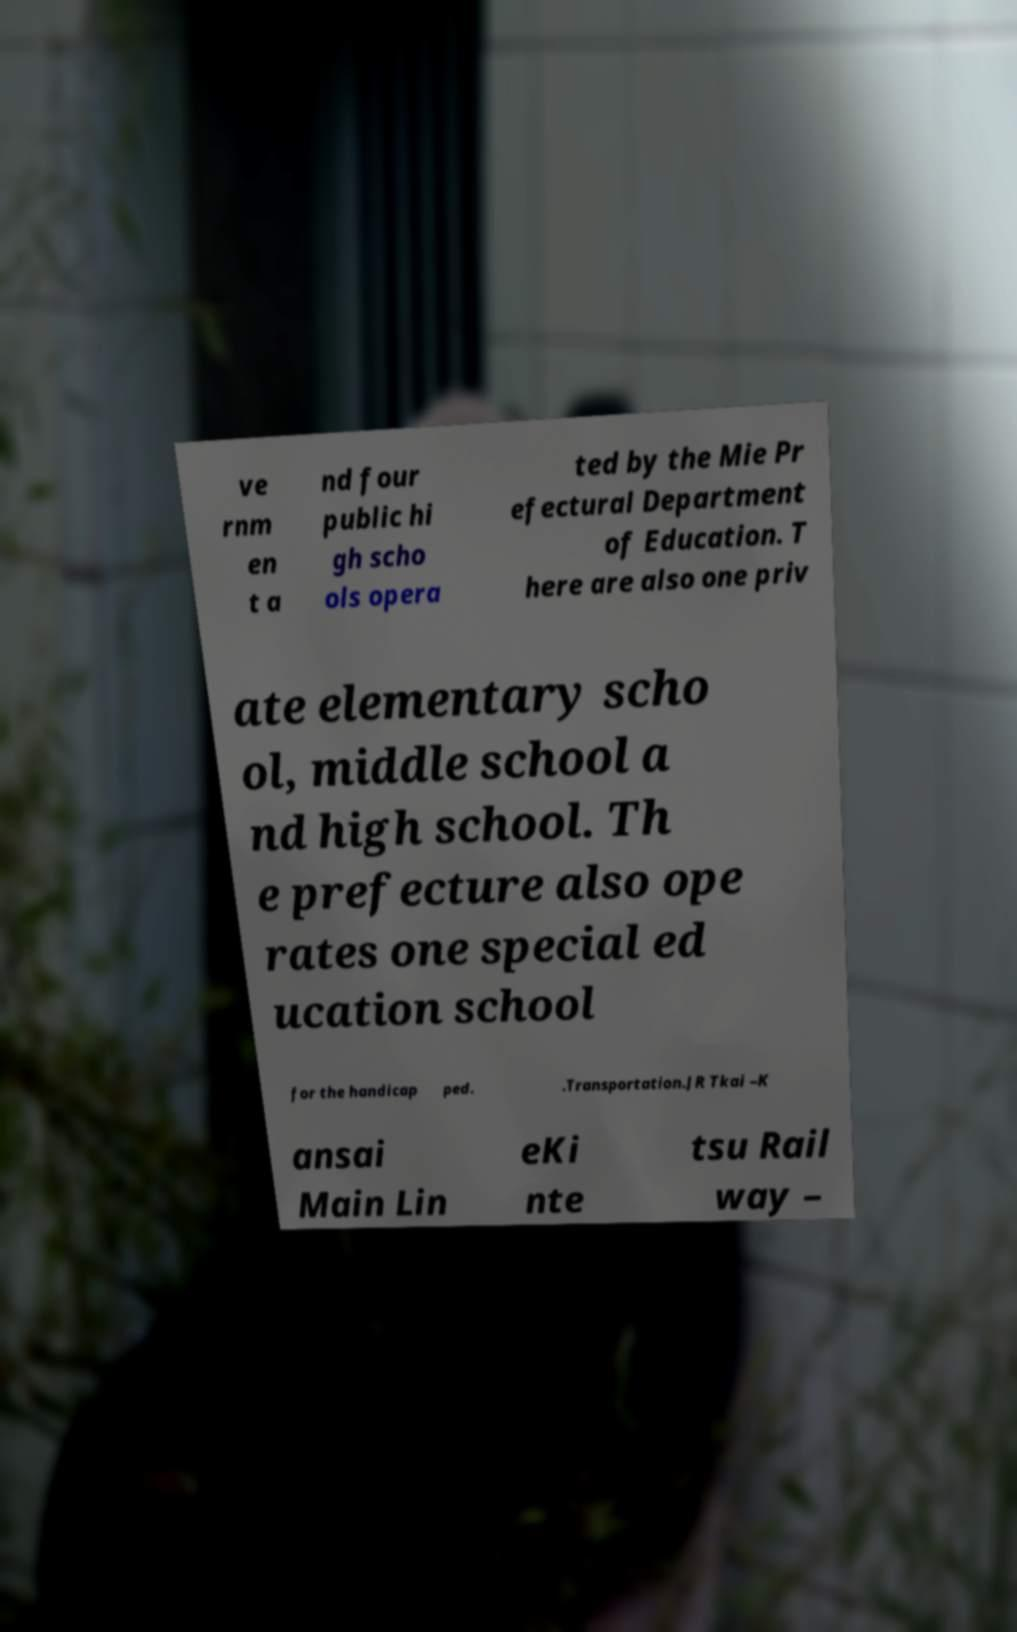Could you assist in decoding the text presented in this image and type it out clearly? ve rnm en t a nd four public hi gh scho ols opera ted by the Mie Pr efectural Department of Education. T here are also one priv ate elementary scho ol, middle school a nd high school. Th e prefecture also ope rates one special ed ucation school for the handicap ped. .Transportation.JR Tkai –K ansai Main Lin eKi nte tsu Rail way – 